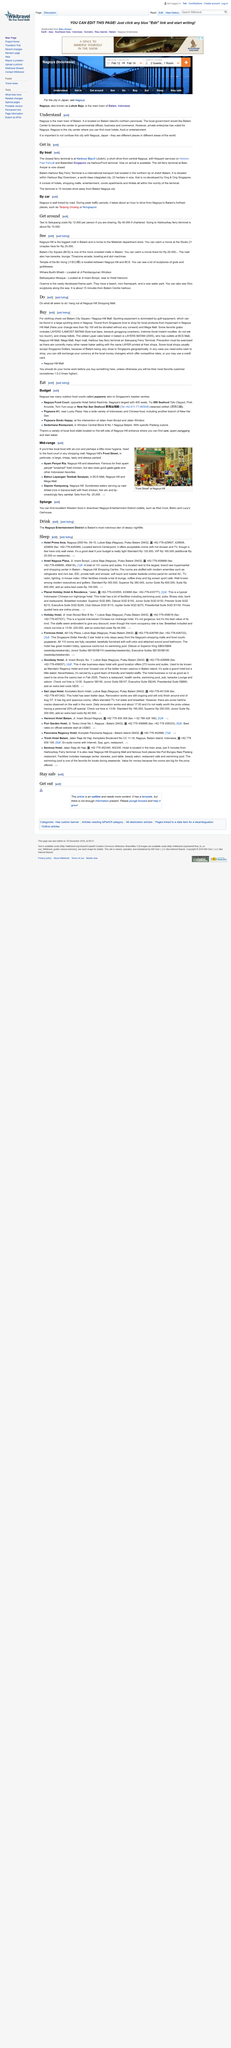Indicate a few pertinent items in this graphic. Dapoer Kampoeng is an eatery that serves rice in banana leaf with fried chicken. Studio 21 cineplex charges Rp 25,000 for a movie ticket. Based on the provided information, it can be declared that Are Bistro and Lucy's Oarhouse are not considered mid-range restaurants. Ayam Penyet Ria is famous for its "smashed" fried chicken. In Batam, the best place to purchase clothing is at the city square or Nagoya Hill Mall, which offer a wide variety of high-quality and fashionable options for all customers. 